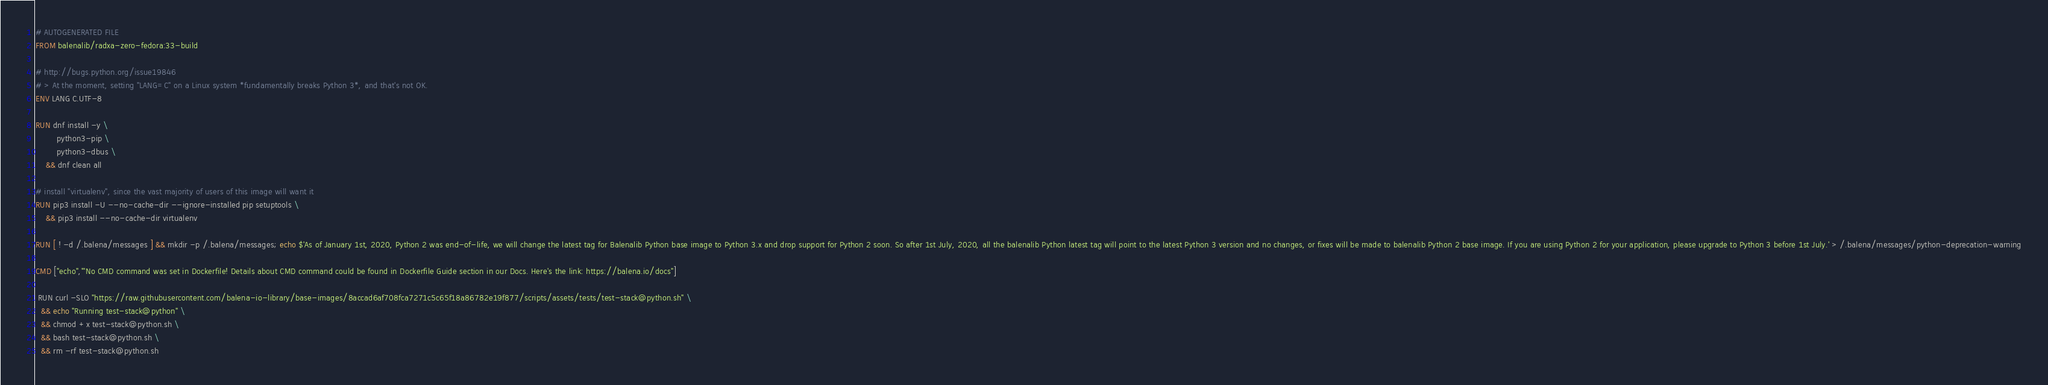<code> <loc_0><loc_0><loc_500><loc_500><_Dockerfile_># AUTOGENERATED FILE
FROM balenalib/radxa-zero-fedora:33-build

# http://bugs.python.org/issue19846
# > At the moment, setting "LANG=C" on a Linux system *fundamentally breaks Python 3*, and that's not OK.
ENV LANG C.UTF-8

RUN dnf install -y \
		python3-pip \
		python3-dbus \
	&& dnf clean all

# install "virtualenv", since the vast majority of users of this image will want it
RUN pip3 install -U --no-cache-dir --ignore-installed pip setuptools \
	&& pip3 install --no-cache-dir virtualenv

RUN [ ! -d /.balena/messages ] && mkdir -p /.balena/messages; echo $'As of January 1st, 2020, Python 2 was end-of-life, we will change the latest tag for Balenalib Python base image to Python 3.x and drop support for Python 2 soon. So after 1st July, 2020, all the balenalib Python latest tag will point to the latest Python 3 version and no changes, or fixes will be made to balenalib Python 2 base image. If you are using Python 2 for your application, please upgrade to Python 3 before 1st July.' > /.balena/messages/python-deprecation-warning

CMD ["echo","'No CMD command was set in Dockerfile! Details about CMD command could be found in Dockerfile Guide section in our Docs. Here's the link: https://balena.io/docs"]

 RUN curl -SLO "https://raw.githubusercontent.com/balena-io-library/base-images/8accad6af708fca7271c5c65f18a86782e19f877/scripts/assets/tests/test-stack@python.sh" \
  && echo "Running test-stack@python" \
  && chmod +x test-stack@python.sh \
  && bash test-stack@python.sh \
  && rm -rf test-stack@python.sh 
</code> 